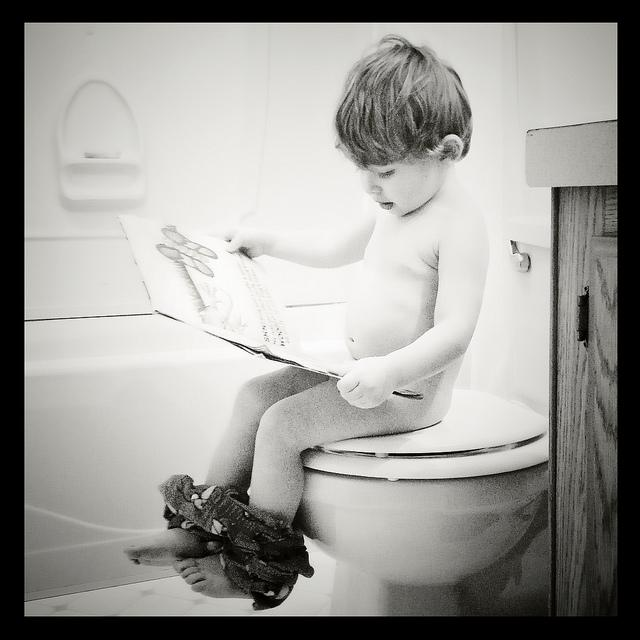What does the child do here? Please explain your reasoning. read. A child is holding a book and looking at it. 